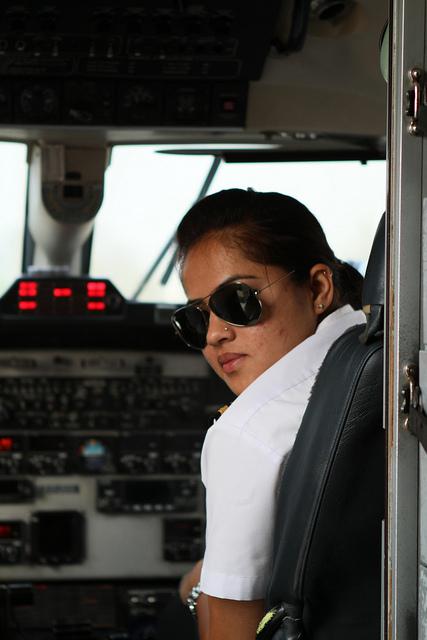Is the women wearing sunglasses?
Quick response, please. Yes. What kind of seat is the lady sitting in?
Short answer required. Pilot. What are the people looking at?
Keep it brief. Camera. Where is she?
Write a very short answer. Cockpit. 